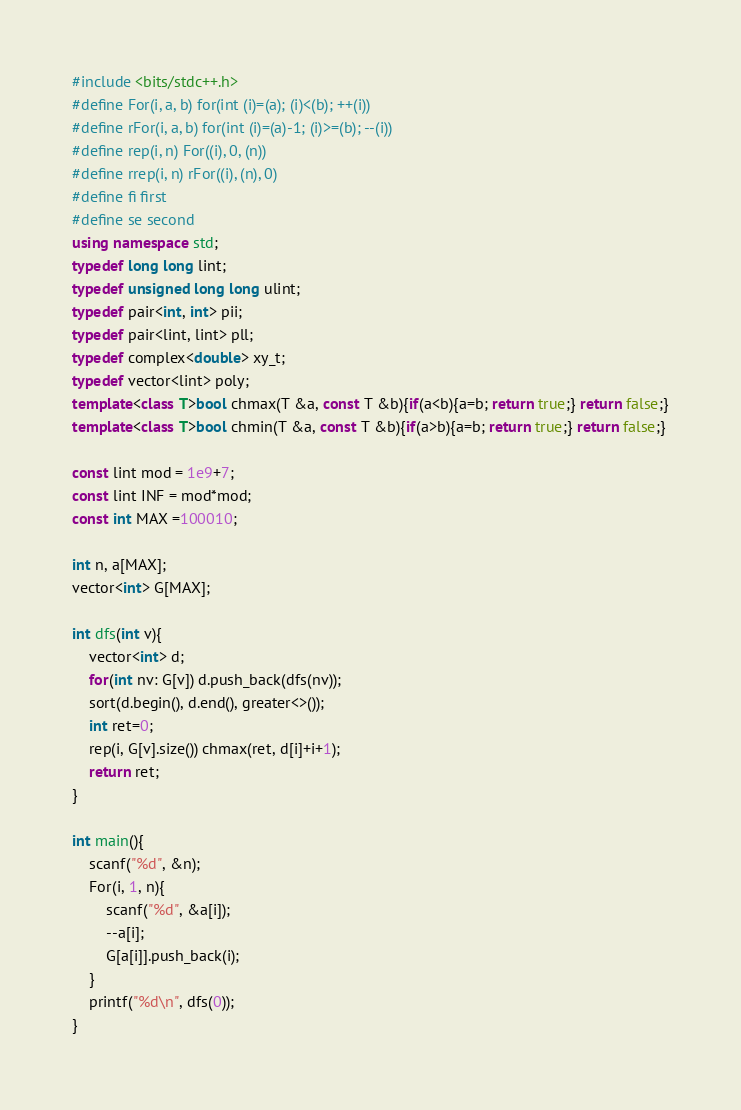<code> <loc_0><loc_0><loc_500><loc_500><_C++_>#include <bits/stdc++.h>
#define For(i, a, b) for(int (i)=(a); (i)<(b); ++(i))
#define rFor(i, a, b) for(int (i)=(a)-1; (i)>=(b); --(i))
#define rep(i, n) For((i), 0, (n))
#define rrep(i, n) rFor((i), (n), 0)
#define fi first
#define se second
using namespace std;
typedef long long lint;
typedef unsigned long long ulint;
typedef pair<int, int> pii;
typedef pair<lint, lint> pll;
typedef complex<double> xy_t;
typedef vector<lint> poly;
template<class T>bool chmax(T &a, const T &b){if(a<b){a=b; return true;} return false;}
template<class T>bool chmin(T &a, const T &b){if(a>b){a=b; return true;} return false;}

const lint mod = 1e9+7;
const lint INF = mod*mod;
const int MAX =100010;

int n, a[MAX];
vector<int> G[MAX];

int dfs(int v){
    vector<int> d;
    for(int nv: G[v]) d.push_back(dfs(nv));
    sort(d.begin(), d.end(), greater<>());
    int ret=0;
    rep(i, G[v].size()) chmax(ret, d[i]+i+1);
    return ret;
}

int main(){
    scanf("%d", &n);
    For(i, 1, n){
        scanf("%d", &a[i]);
        --a[i];
        G[a[i]].push_back(i);
    }
    printf("%d\n", dfs(0));
}</code> 